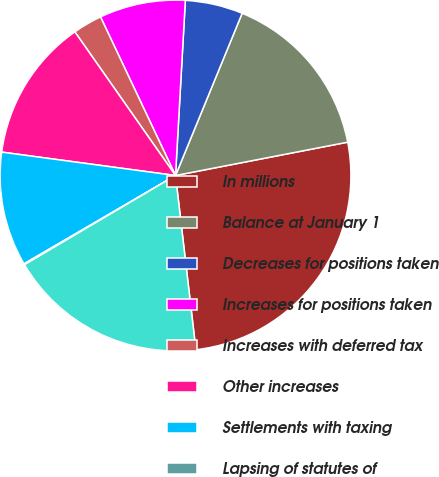Convert chart. <chart><loc_0><loc_0><loc_500><loc_500><pie_chart><fcel>In millions<fcel>Balance at January 1<fcel>Decreases for positions taken<fcel>Increases for positions taken<fcel>Increases with deferred tax<fcel>Other increases<fcel>Settlements with taxing<fcel>Lapsing of statutes of<fcel>Balance at December 31 (1)(2)<nl><fcel>26.19%<fcel>15.75%<fcel>5.31%<fcel>7.92%<fcel>2.7%<fcel>13.14%<fcel>10.53%<fcel>0.09%<fcel>18.36%<nl></chart> 